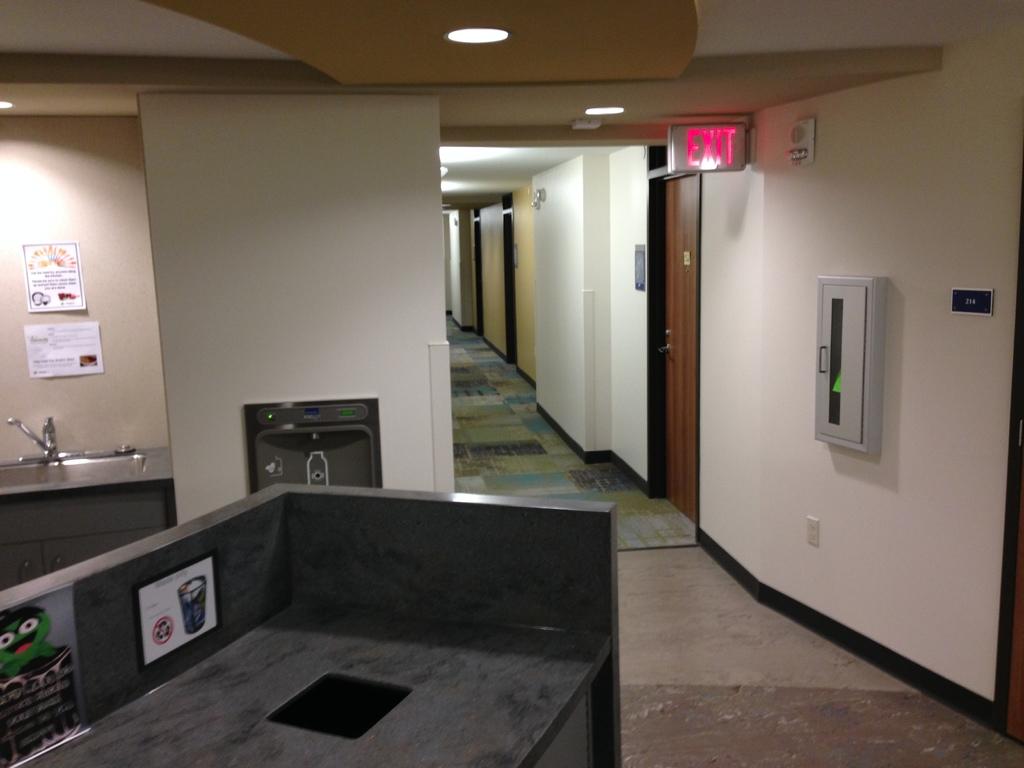What does the sign say by the first door in the hallway?
Your response must be concise. Exit. 